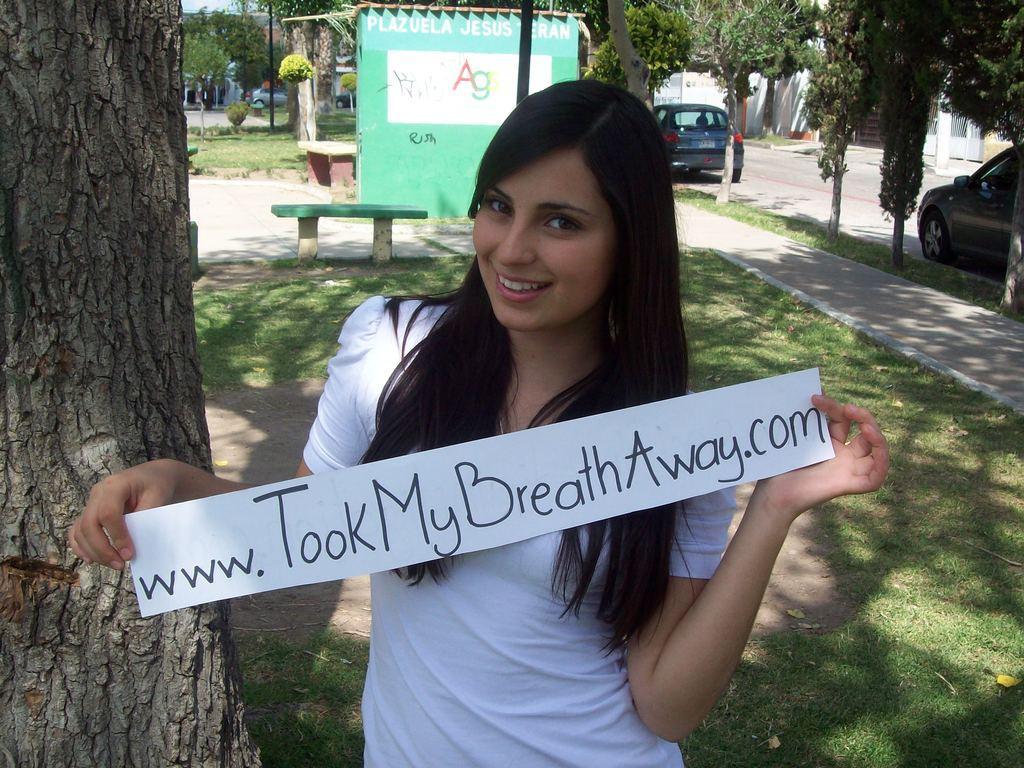In one or two sentences, can you explain what this image depicts? In this image in front there is a person holding the paper. At the bottom of the image there is grass on the surface. On the right side of the image there are cars on the road. In the background of the image there are benches, buildings, trees. 